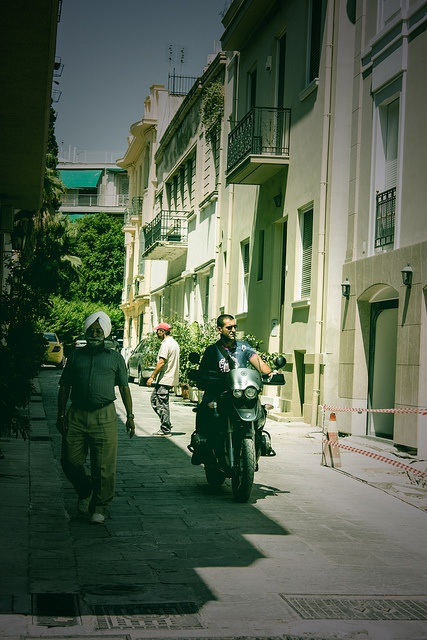Describe the objects in this image and their specific colors. I can see people in black, darkgreen, and darkgray tones, motorcycle in black, darkgreen, and ivory tones, people in black, darkgreen, teal, and tan tones, people in black, ivory, olive, and darkgreen tones, and car in black, olive, and darkgreen tones in this image. 